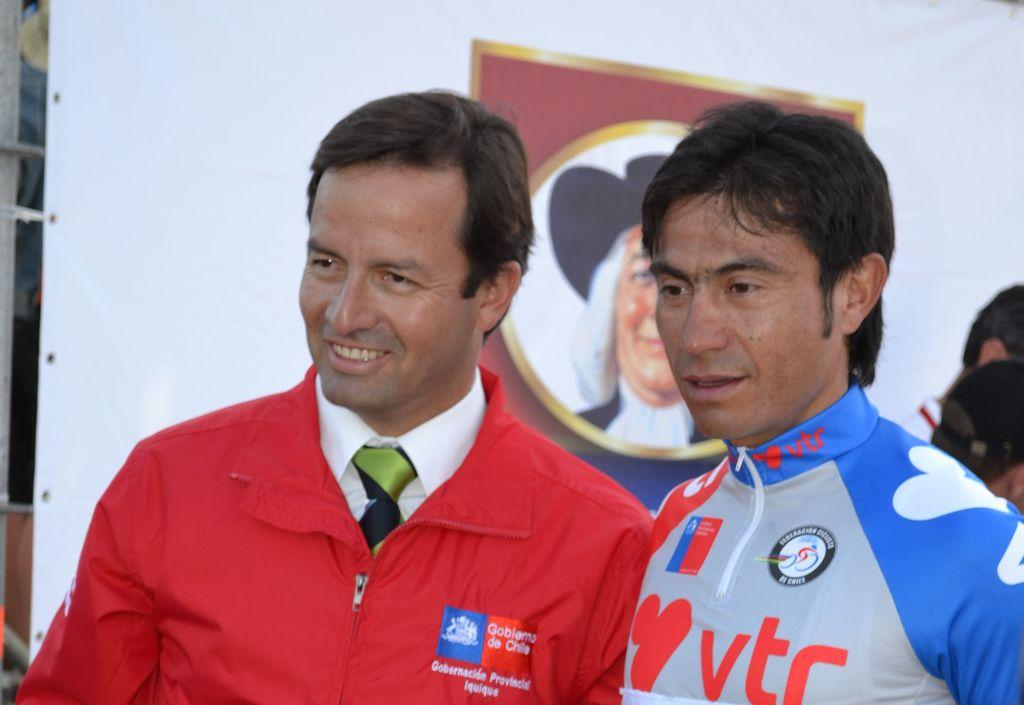<image>
Summarize the visual content of the image. Man taking a picture with another man wearing a shirt that says VTC. 